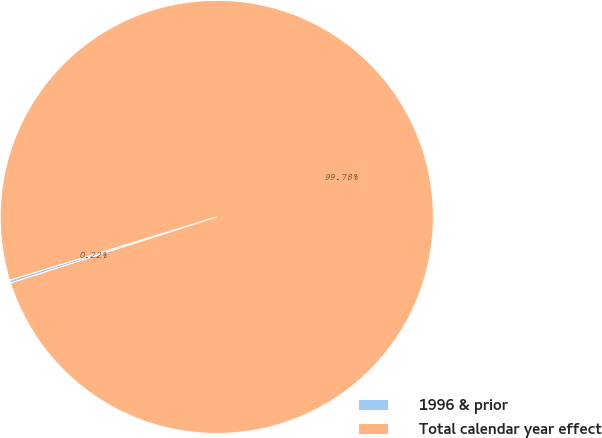<chart> <loc_0><loc_0><loc_500><loc_500><pie_chart><fcel>1996 & prior<fcel>Total calendar year effect<nl><fcel>0.22%<fcel>99.78%<nl></chart> 